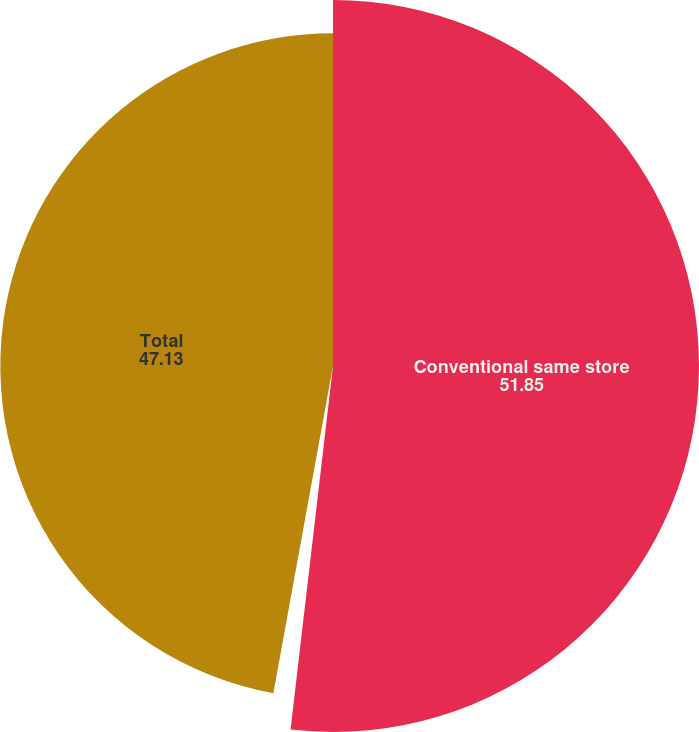Convert chart to OTSL. <chart><loc_0><loc_0><loc_500><loc_500><pie_chart><fcel>Conventional same store<fcel>Other Conventional<fcel>Total<nl><fcel>51.85%<fcel>1.02%<fcel>47.13%<nl></chart> 